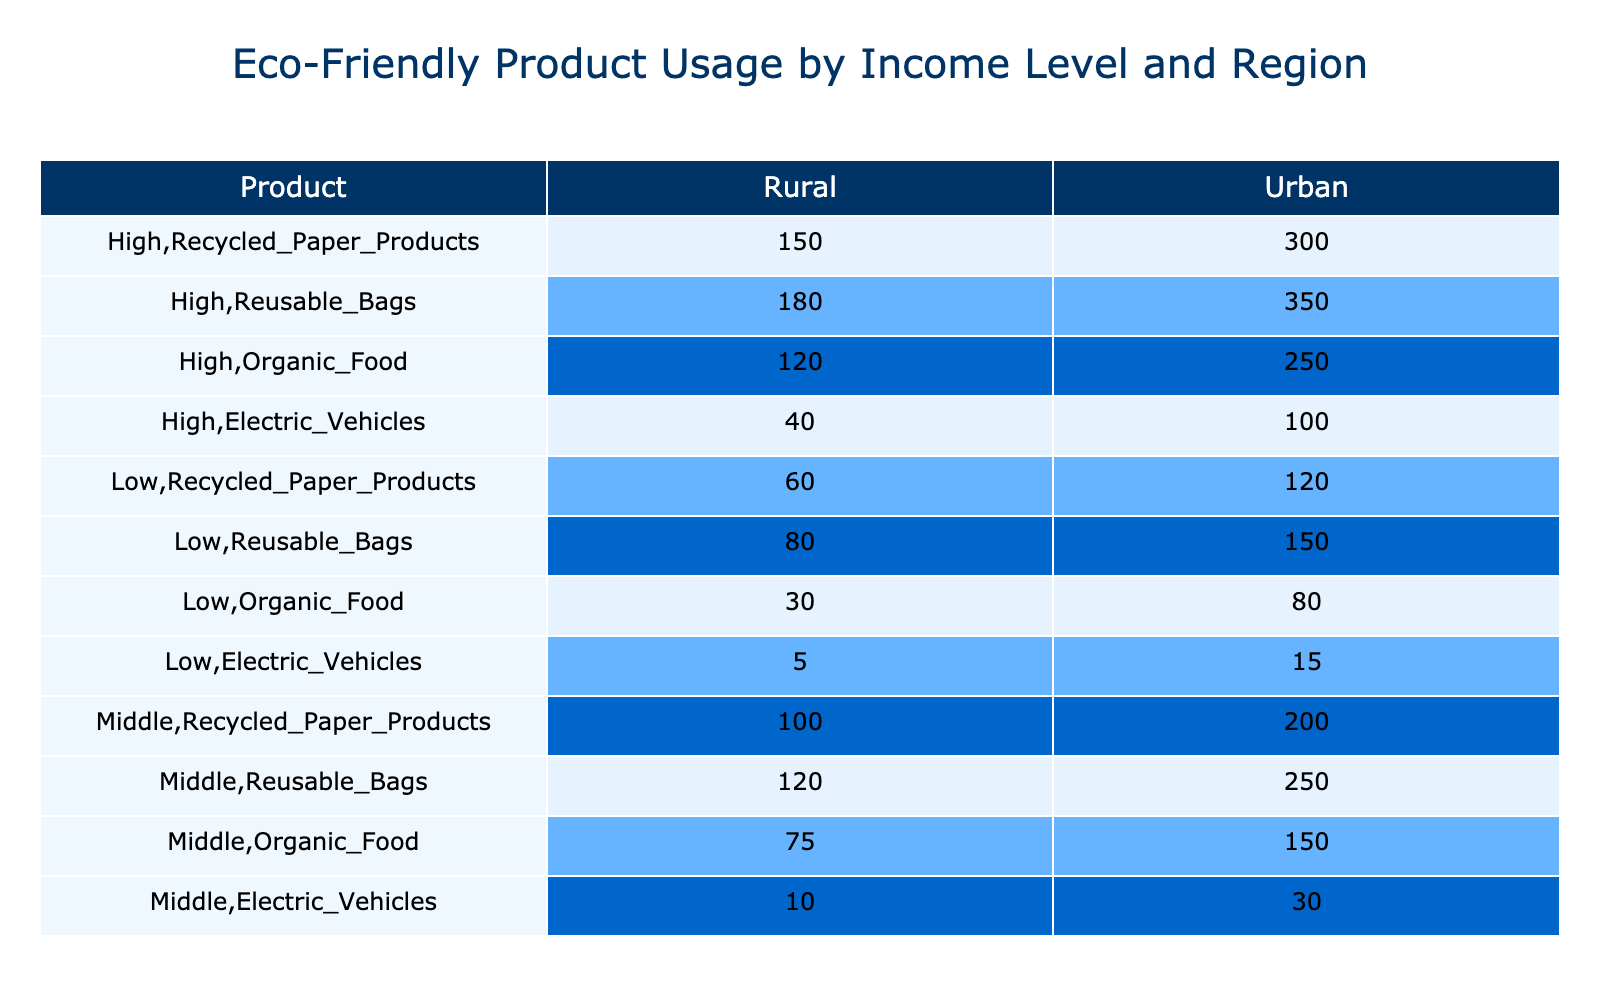What is the total usage of Electric Vehicles in Urban areas? To find the total usage of Electric Vehicles in Urban areas, I need to sum the values from both income levels: For Low income, usage is 15; for Middle income, it's 30; and for High income, it's 100. Therefore, 15 + 30 + 100 = 145.
Answer: 145 What is the maximum number of Reusable Bags used by any income level? By checking the values in the Reusable Bags column, I can see that Low income in Urban has 150, Middle income in Urban has 250, High income in Urban has 350, and Rural areas have lower values. The highest value among these is 350, from the High income in Urban.
Answer: 350 How many more people in High income Urban use Organic Food than in Low income Rural? The usage of Organic Food for High income in Urban is 250, and for Low income in Rural, it is 30. To find the difference, I subtract: 250 - 30 = 220.
Answer: 220 Is it true that Middle income Urban has a higher usage of Recycled Paper Products than Low income Urban? Middle income Urban has a usage of 200, while Low income Urban has 120. Since 200 is greater than 120, it is indeed true that Middle income Urban has a higher usage of Recycled Paper Products.
Answer: Yes What is the average number of Organic Food users in Rural areas across all income levels? In Rural areas, the values for Organic Food are: 30 (Low), 75 (Middle), and 120 (High). To find the average, I sum these values: 30 + 75 + 120 = 225. Then, I divide by the number of income levels, which is 3. So, 225/3 = 75.
Answer: 75 What is the total number of Recycled Paper Products used by all Rural income levels? I will find the total by summing the Recycled Paper Products for Low Rural (60), Middle Rural (100), and High Rural (150). The calculation is: 60 + 100 + 150 = 310.
Answer: 310 Does the usage of Electric Vehicles among Rural regions exceed that of Urban regions combined? In Urban regions, Electric Vehicle usage totals 145, while in Rural regions, it is 55 (5 for Low + 10 for Middle + 40 for High). Since 55 is less than 145, it is false that Rural regions exceed Urban regions.
Answer: No What is the difference in Reusable Bags usage between High income Urban and High income Rural? The usage of Reusable Bags for High income Urban is 350, and for High income Rural, it is 180. To find the difference, I subtract: 350 - 180 = 170.
Answer: 170 